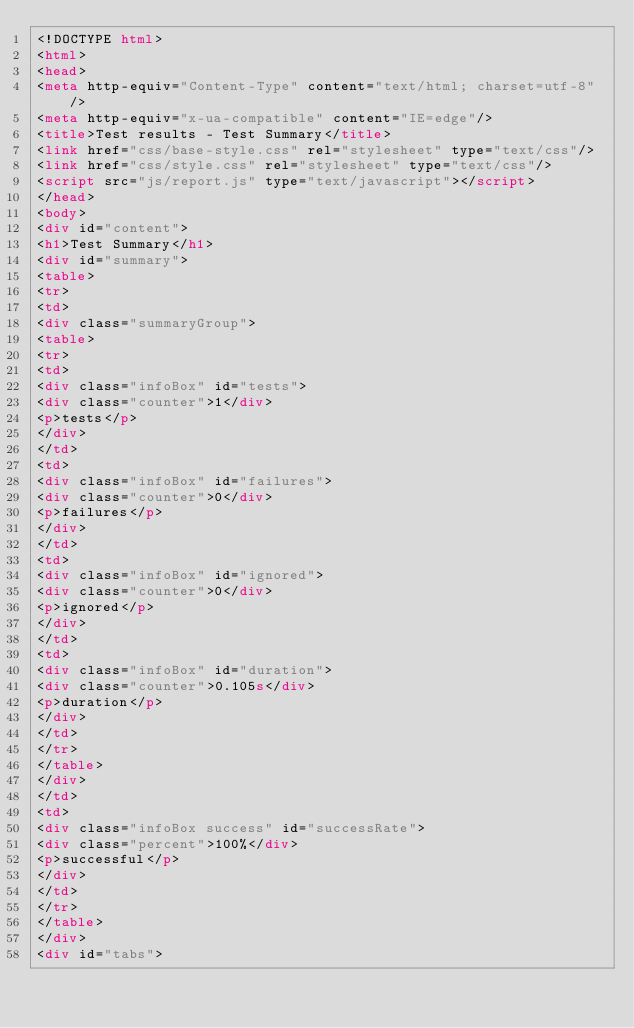Convert code to text. <code><loc_0><loc_0><loc_500><loc_500><_HTML_><!DOCTYPE html>
<html>
<head>
<meta http-equiv="Content-Type" content="text/html; charset=utf-8"/>
<meta http-equiv="x-ua-compatible" content="IE=edge"/>
<title>Test results - Test Summary</title>
<link href="css/base-style.css" rel="stylesheet" type="text/css"/>
<link href="css/style.css" rel="stylesheet" type="text/css"/>
<script src="js/report.js" type="text/javascript"></script>
</head>
<body>
<div id="content">
<h1>Test Summary</h1>
<div id="summary">
<table>
<tr>
<td>
<div class="summaryGroup">
<table>
<tr>
<td>
<div class="infoBox" id="tests">
<div class="counter">1</div>
<p>tests</p>
</div>
</td>
<td>
<div class="infoBox" id="failures">
<div class="counter">0</div>
<p>failures</p>
</div>
</td>
<td>
<div class="infoBox" id="ignored">
<div class="counter">0</div>
<p>ignored</p>
</div>
</td>
<td>
<div class="infoBox" id="duration">
<div class="counter">0.105s</div>
<p>duration</p>
</div>
</td>
</tr>
</table>
</div>
</td>
<td>
<div class="infoBox success" id="successRate">
<div class="percent">100%</div>
<p>successful</p>
</div>
</td>
</tr>
</table>
</div>
<div id="tabs"></code> 